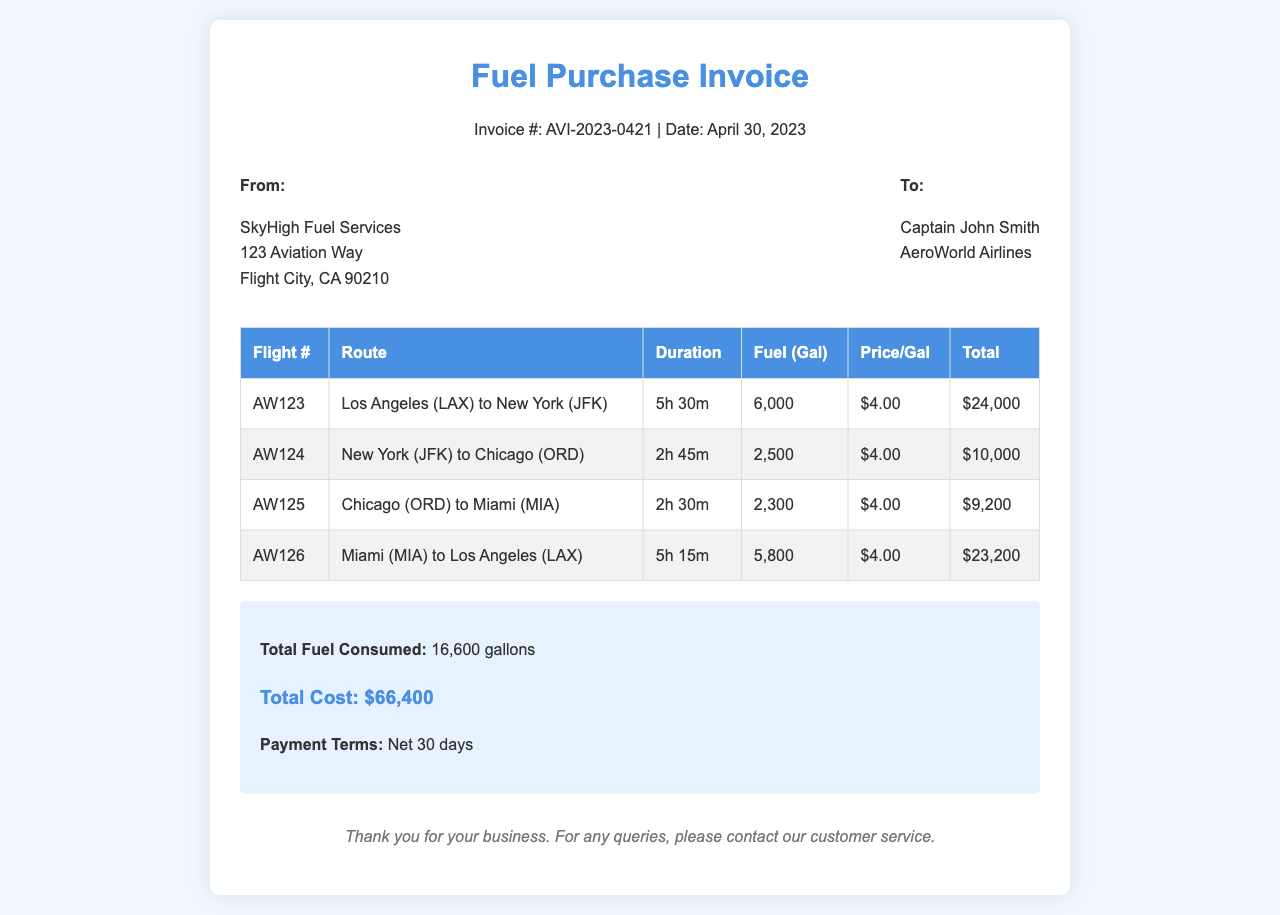What is the invoice number? The invoice number is provided at the top of the document, listed as "Invoice #: AVI-2023-0421."
Answer: AVI-2023-0421 What is the total cost? The total cost is calculated and presented in the summary section of the document, which is $66,400.
Answer: $66,400 How many gallons of fuel were consumed? The total fuel consumed is detailed in the summary section, which states 16,600 gallons.
Answer: 16,600 gallons What is the price per gallon of fuel? The price per gallon is listed in the table for each flight, consistently noted as $4.00.
Answer: $4.00 Which route corresponds to Flight AW123? The route for Flight AW123 is provided in the table under the 'Route' column, which is Los Angeles (LAX) to New York (JFK).
Answer: Los Angeles (LAX) to New York (JFK) What is the flight duration from Miami to Los Angeles? The flight duration for Miami (MIA) to Los Angeles (LAX) is indicated in the table, which is 5h 15m.
Answer: 5h 15m Who is the invoice addressed to? The recipient's name is listed in the 'To' section of the invoice, which is Captain John Smith.
Answer: Captain John Smith What are the payment terms stated in the invoice? The payment terms are clearly mentioned in the summary section of the document, stating "Net 30 days."
Answer: Net 30 days 